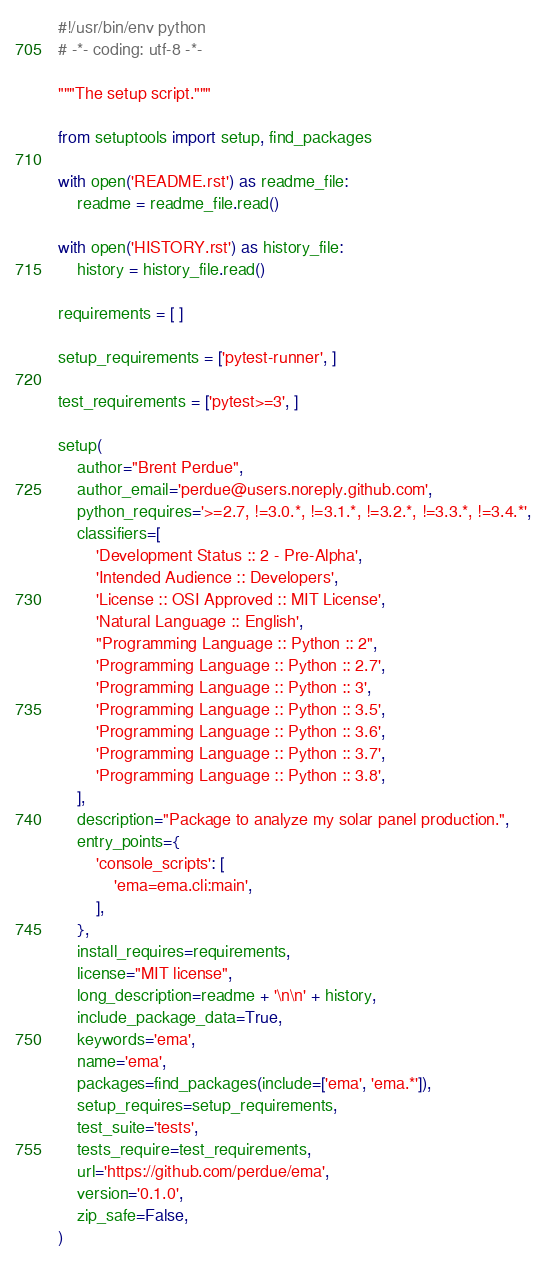<code> <loc_0><loc_0><loc_500><loc_500><_Python_>#!/usr/bin/env python
# -*- coding: utf-8 -*-

"""The setup script."""

from setuptools import setup, find_packages

with open('README.rst') as readme_file:
    readme = readme_file.read()

with open('HISTORY.rst') as history_file:
    history = history_file.read()

requirements = [ ]

setup_requirements = ['pytest-runner', ]

test_requirements = ['pytest>=3', ]

setup(
    author="Brent Perdue",
    author_email='perdue@users.noreply.github.com',
    python_requires='>=2.7, !=3.0.*, !=3.1.*, !=3.2.*, !=3.3.*, !=3.4.*',
    classifiers=[
        'Development Status :: 2 - Pre-Alpha',
        'Intended Audience :: Developers',
        'License :: OSI Approved :: MIT License',
        'Natural Language :: English',
        "Programming Language :: Python :: 2",
        'Programming Language :: Python :: 2.7',
        'Programming Language :: Python :: 3',
        'Programming Language :: Python :: 3.5',
        'Programming Language :: Python :: 3.6',
        'Programming Language :: Python :: 3.7',
        'Programming Language :: Python :: 3.8',
    ],
    description="Package to analyze my solar panel production.",
    entry_points={
        'console_scripts': [
            'ema=ema.cli:main',
        ],
    },
    install_requires=requirements,
    license="MIT license",
    long_description=readme + '\n\n' + history,
    include_package_data=True,
    keywords='ema',
    name='ema',
    packages=find_packages(include=['ema', 'ema.*']),
    setup_requires=setup_requirements,
    test_suite='tests',
    tests_require=test_requirements,
    url='https://github.com/perdue/ema',
    version='0.1.0',
    zip_safe=False,
)
</code> 